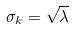Convert formula to latex. <formula><loc_0><loc_0><loc_500><loc_500>\sigma _ { k } = \sqrt { \lambda }</formula> 